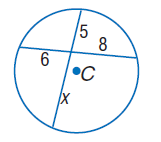Question: Find x. Assume that segments that appear to be tangent are tangent.
Choices:
A. 6
B. 8
C. 9.6
D. 14.6
Answer with the letter. Answer: C 